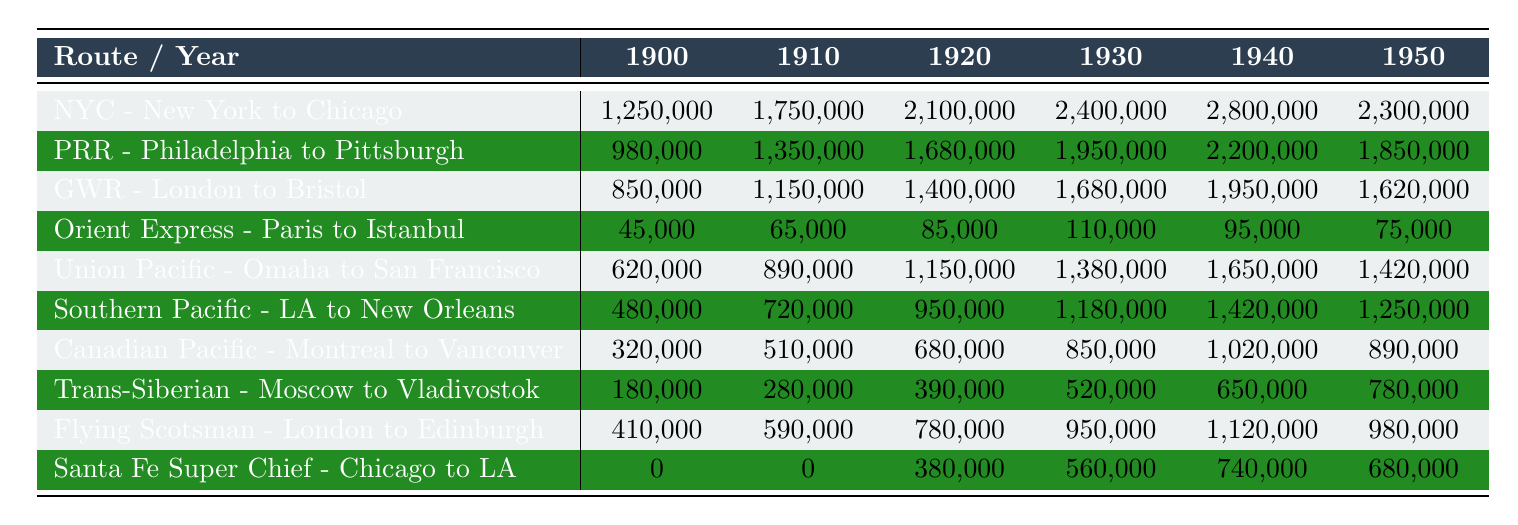What was the passenger count for the Union Pacific route in 1940? Referring to the row for Union Pacific - Omaha to San Francisco, the value for 1940 is clearly stated as 1,650,000 passengers.
Answer: 1,650,000 Which route had the highest passenger count in 1930? By examining the row for each route in the year 1930, the New York Central route shows the highest value at 2,400,000 passengers.
Answer: New York Central (NYC) - New York to Chicago What was the total passenger count for the Great Western Railway from 1900 to 1950? Adding the values for the Great Western Railway from each year: 850,000 + 1,150,000 + 1,400,000 + 1,680,000 + 1,950,000 + 1,620,000 gives us 8,650,000.
Answer: 8,650,000 Did the passenger count for the Orient Express increase from 1920 to 1930? Comparing the values, in 1920 there were 85,000 passengers and in 1930 there were 110,000 passengers, showing an increase.
Answer: Yes What was the average passenger count for the Santa Fe Super Chief over the years it operated from 1920 to 1950? The values from 1920 to 1950 are 380,000, 560,000, 740,000, and 680,000. Adding these gives 2,360,000; dividing by 4 (the number of years) gives an average of 590,000.
Answer: 590,000 Which route had the lowest total passengers over the entire period? By calculating the total passengers for each route, the Orient Express has the lowest total of 455,000 passengers.
Answer: Orient Express - Paris to Istanbul How much did the passenger count for the Canadian Pacific Railway decrease from 1940 to 1950? The count for 1940 is 1,020,000 and for 1950 it is 890,000. The difference is 1,020,000 - 890,000 = 130,000, meaning it decreased by this amount.
Answer: 130,000 Which route saw the largest increase in passengers from 1900 to 1950? By analyzing the change from 1900 to 1950, the New York Central route increased from 1,250,000 to 2,300,000, a rise of 1,050,000, which is the largest increase among all routes.
Answer: New York Central (NYC) - New York to Chicago In which year did the Flying Scotsman have a passenger count above 900,000? Checking the row for the Flying Scotsman, we find that it exceeded 900,000 in the years 1930 (950,000) and 1940 (1,120,000).
Answer: 1930 and 1940 What percentage of the total passengers in 1950 does the Southern Pacific route account for? The total passengers from all routes in 1950 is 9,040,000, and the Southern Pacific had 1,250,000. The percentage is (1,250,000 / 9,040,000) * 100 ≈ 13.84%.
Answer: Approximately 13.84% 